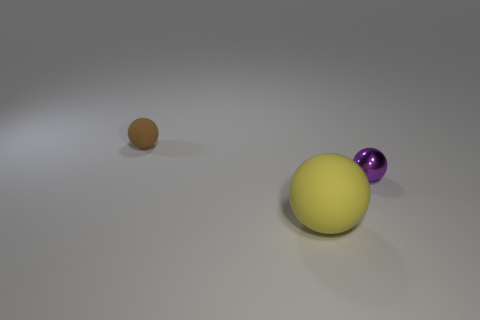Are there any other things that are the same material as the purple sphere?
Your response must be concise. No. What number of other things are the same color as the shiny sphere?
Give a very brief answer. 0. Is the number of yellow rubber objects that are in front of the large rubber thing greater than the number of big objects that are behind the small shiny thing?
Your response must be concise. No. There is a purple thing; are there any big matte balls behind it?
Offer a terse response. No. The sphere that is on the left side of the small purple thing and in front of the brown matte thing is made of what material?
Give a very brief answer. Rubber. There is another matte thing that is the same shape as the yellow matte thing; what color is it?
Offer a very short reply. Brown. Is there a purple sphere in front of the rubber sphere that is to the right of the small rubber ball?
Offer a very short reply. No. The metal object is what size?
Your answer should be very brief. Small. What shape is the object that is both behind the big yellow thing and to the left of the small metal thing?
Ensure brevity in your answer.  Sphere. What number of cyan objects are large objects or small objects?
Give a very brief answer. 0. 